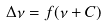Convert formula to latex. <formula><loc_0><loc_0><loc_500><loc_500>\Delta \nu = f ( \nu + C )</formula> 